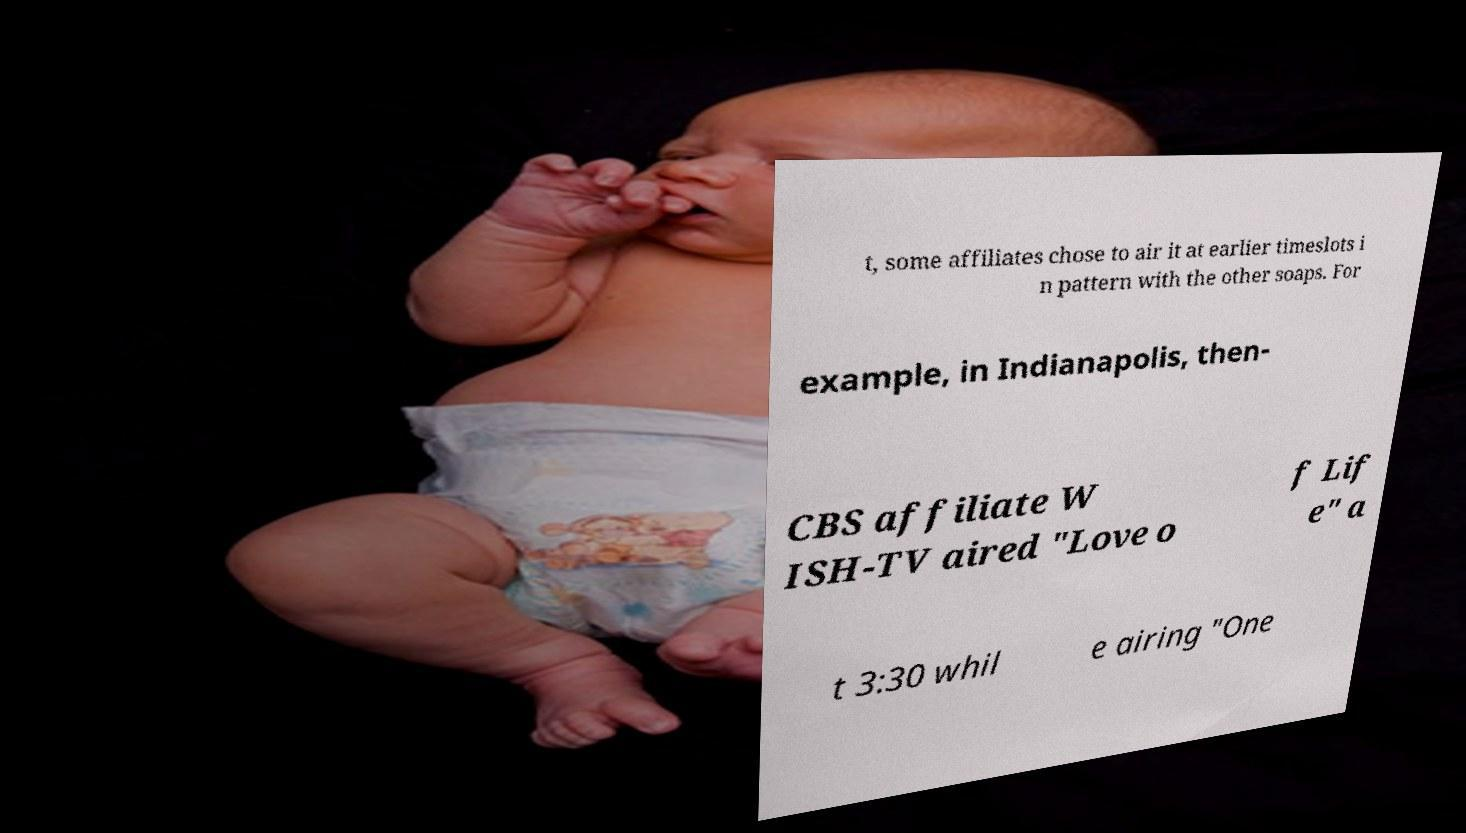Could you assist in decoding the text presented in this image and type it out clearly? t, some affiliates chose to air it at earlier timeslots i n pattern with the other soaps. For example, in Indianapolis, then- CBS affiliate W ISH-TV aired "Love o f Lif e" a t 3:30 whil e airing "One 